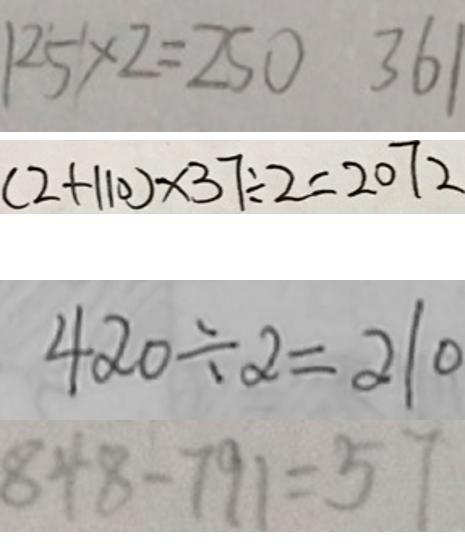Convert formula to latex. <formula><loc_0><loc_0><loc_500><loc_500>1 2 5 \times 2 = 2 5 0 3 6 1 
 ( 2 + 1 1 0 ) \times 3 7 \div 2 = 2 0 7 2 
 4 2 0 \div 2 = 2 1 0 
 8 4 8 - 7 9 1 = 5 7</formula> 